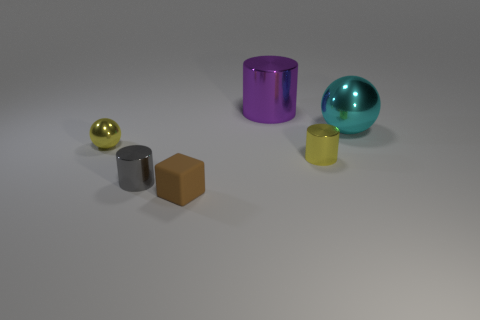How many other things are the same material as the small gray object?
Keep it short and to the point. 4. How many other objects are the same shape as the tiny brown rubber thing?
Offer a terse response. 0. Is the size of the sphere left of the purple thing the same as the purple metallic object?
Make the answer very short. No. Is the number of small brown matte cubes that are behind the small matte thing greater than the number of small cubes?
Offer a very short reply. No. There is a large metallic object on the left side of the cyan shiny thing; how many things are right of it?
Make the answer very short. 2. Are there fewer tiny yellow metal things to the left of the gray cylinder than cyan rubber cylinders?
Make the answer very short. No. There is a thing that is on the left side of the cylinder that is to the left of the brown matte block; are there any small gray metal cylinders right of it?
Provide a succinct answer. Yes. Is the material of the cyan ball the same as the small cylinder on the left side of the brown matte block?
Provide a succinct answer. Yes. There is a sphere that is on the left side of the cylinder that is behind the large sphere; what is its color?
Offer a very short reply. Yellow. Is there a metal cylinder of the same color as the tiny shiny ball?
Keep it short and to the point. Yes. 